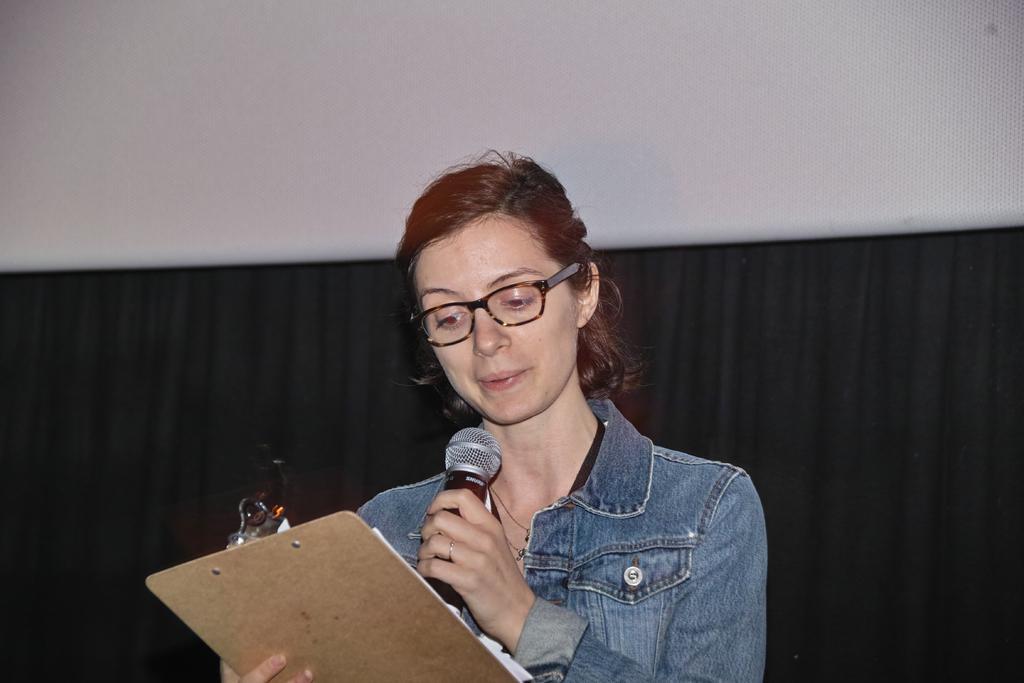Please provide a concise description of this image. In this image we can see a woman standing and holding plank and mic in her hands. In the background there is a curtain to the wall. 